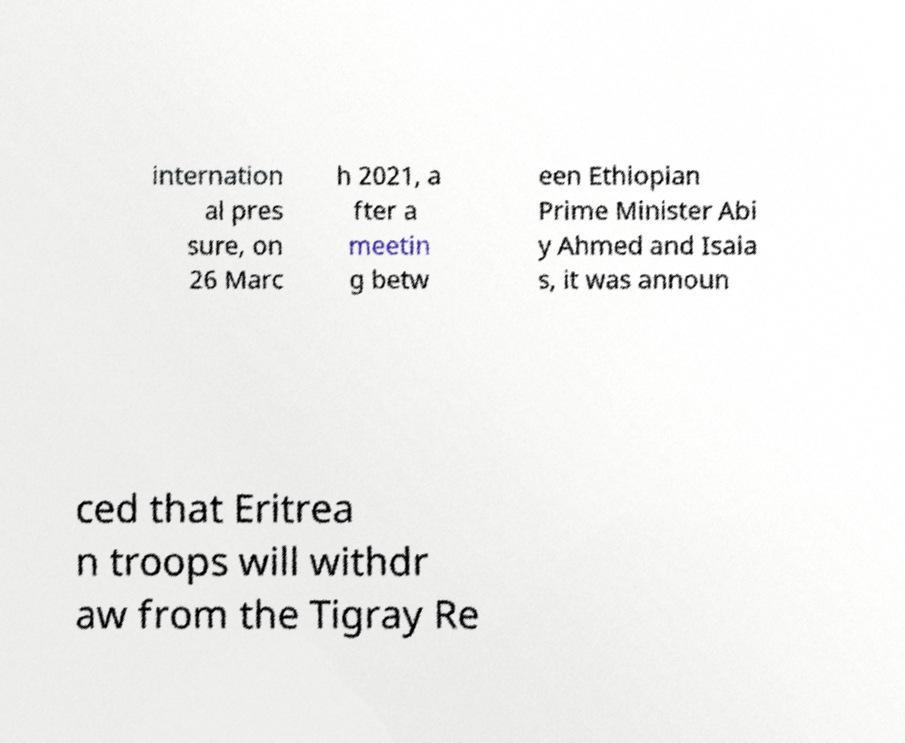What messages or text are displayed in this image? I need them in a readable, typed format. internation al pres sure, on 26 Marc h 2021, a fter a meetin g betw een Ethiopian Prime Minister Abi y Ahmed and Isaia s, it was announ ced that Eritrea n troops will withdr aw from the Tigray Re 